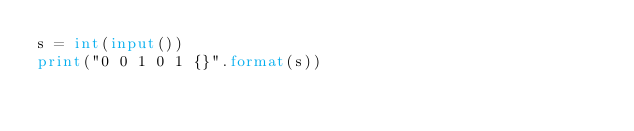Convert code to text. <code><loc_0><loc_0><loc_500><loc_500><_Python_>s = int(input())
print("0 0 1 0 1 {}".format(s))</code> 